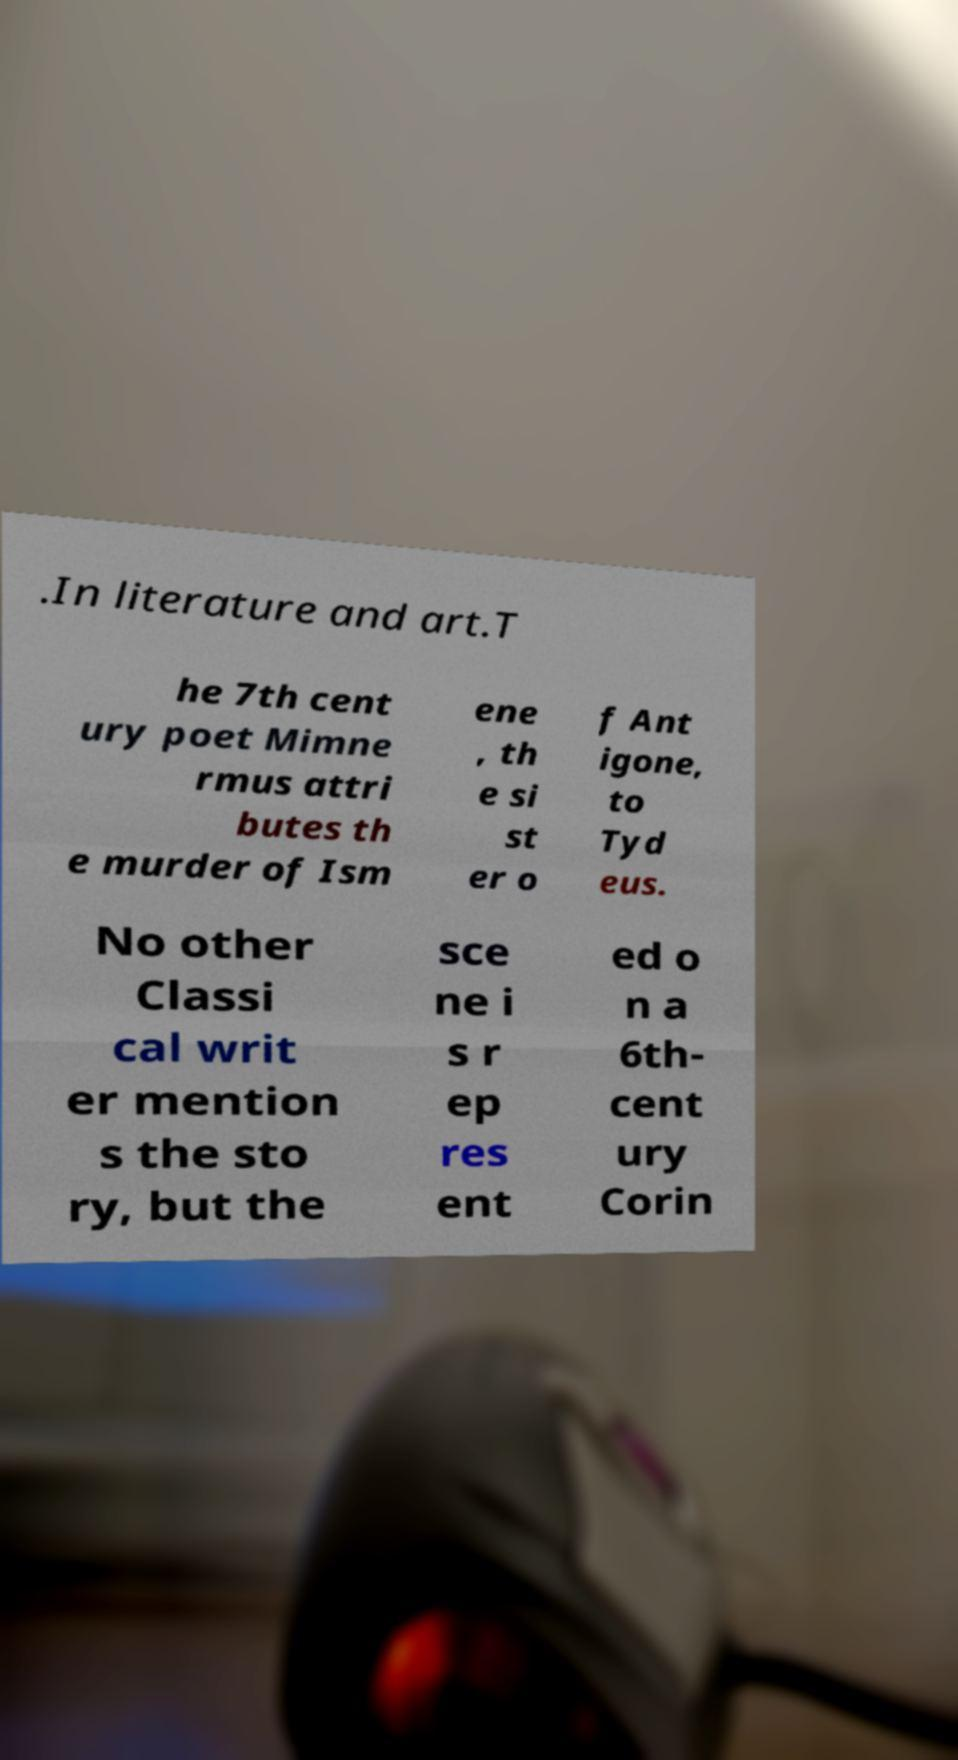Please read and relay the text visible in this image. What does it say? .In literature and art.T he 7th cent ury poet Mimne rmus attri butes th e murder of Ism ene , th e si st er o f Ant igone, to Tyd eus. No other Classi cal writ er mention s the sto ry, but the sce ne i s r ep res ent ed o n a 6th- cent ury Corin 